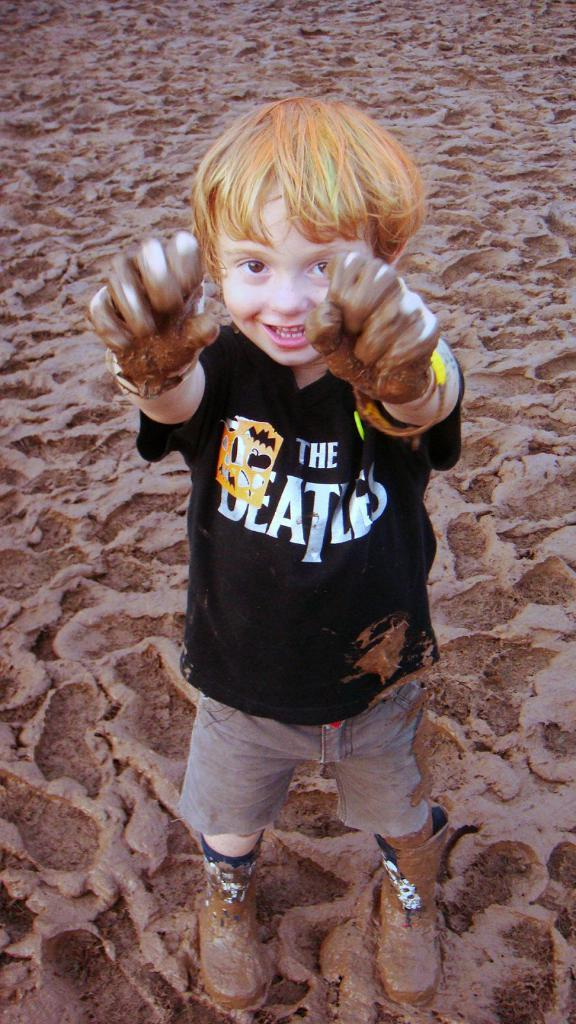What is the main subject of the image? There is a child in the image. What is the child doing in the image? The child is smiling and standing. What is the condition of the ground in the image? There is mud at the bottom of the image. What type of current is flowing through the child's eyes in the image? There is no current flowing through the child's eyes in the image, as eyes do not conduct electricity. 